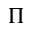Convert formula to latex. <formula><loc_0><loc_0><loc_500><loc_500>\Pi</formula> 